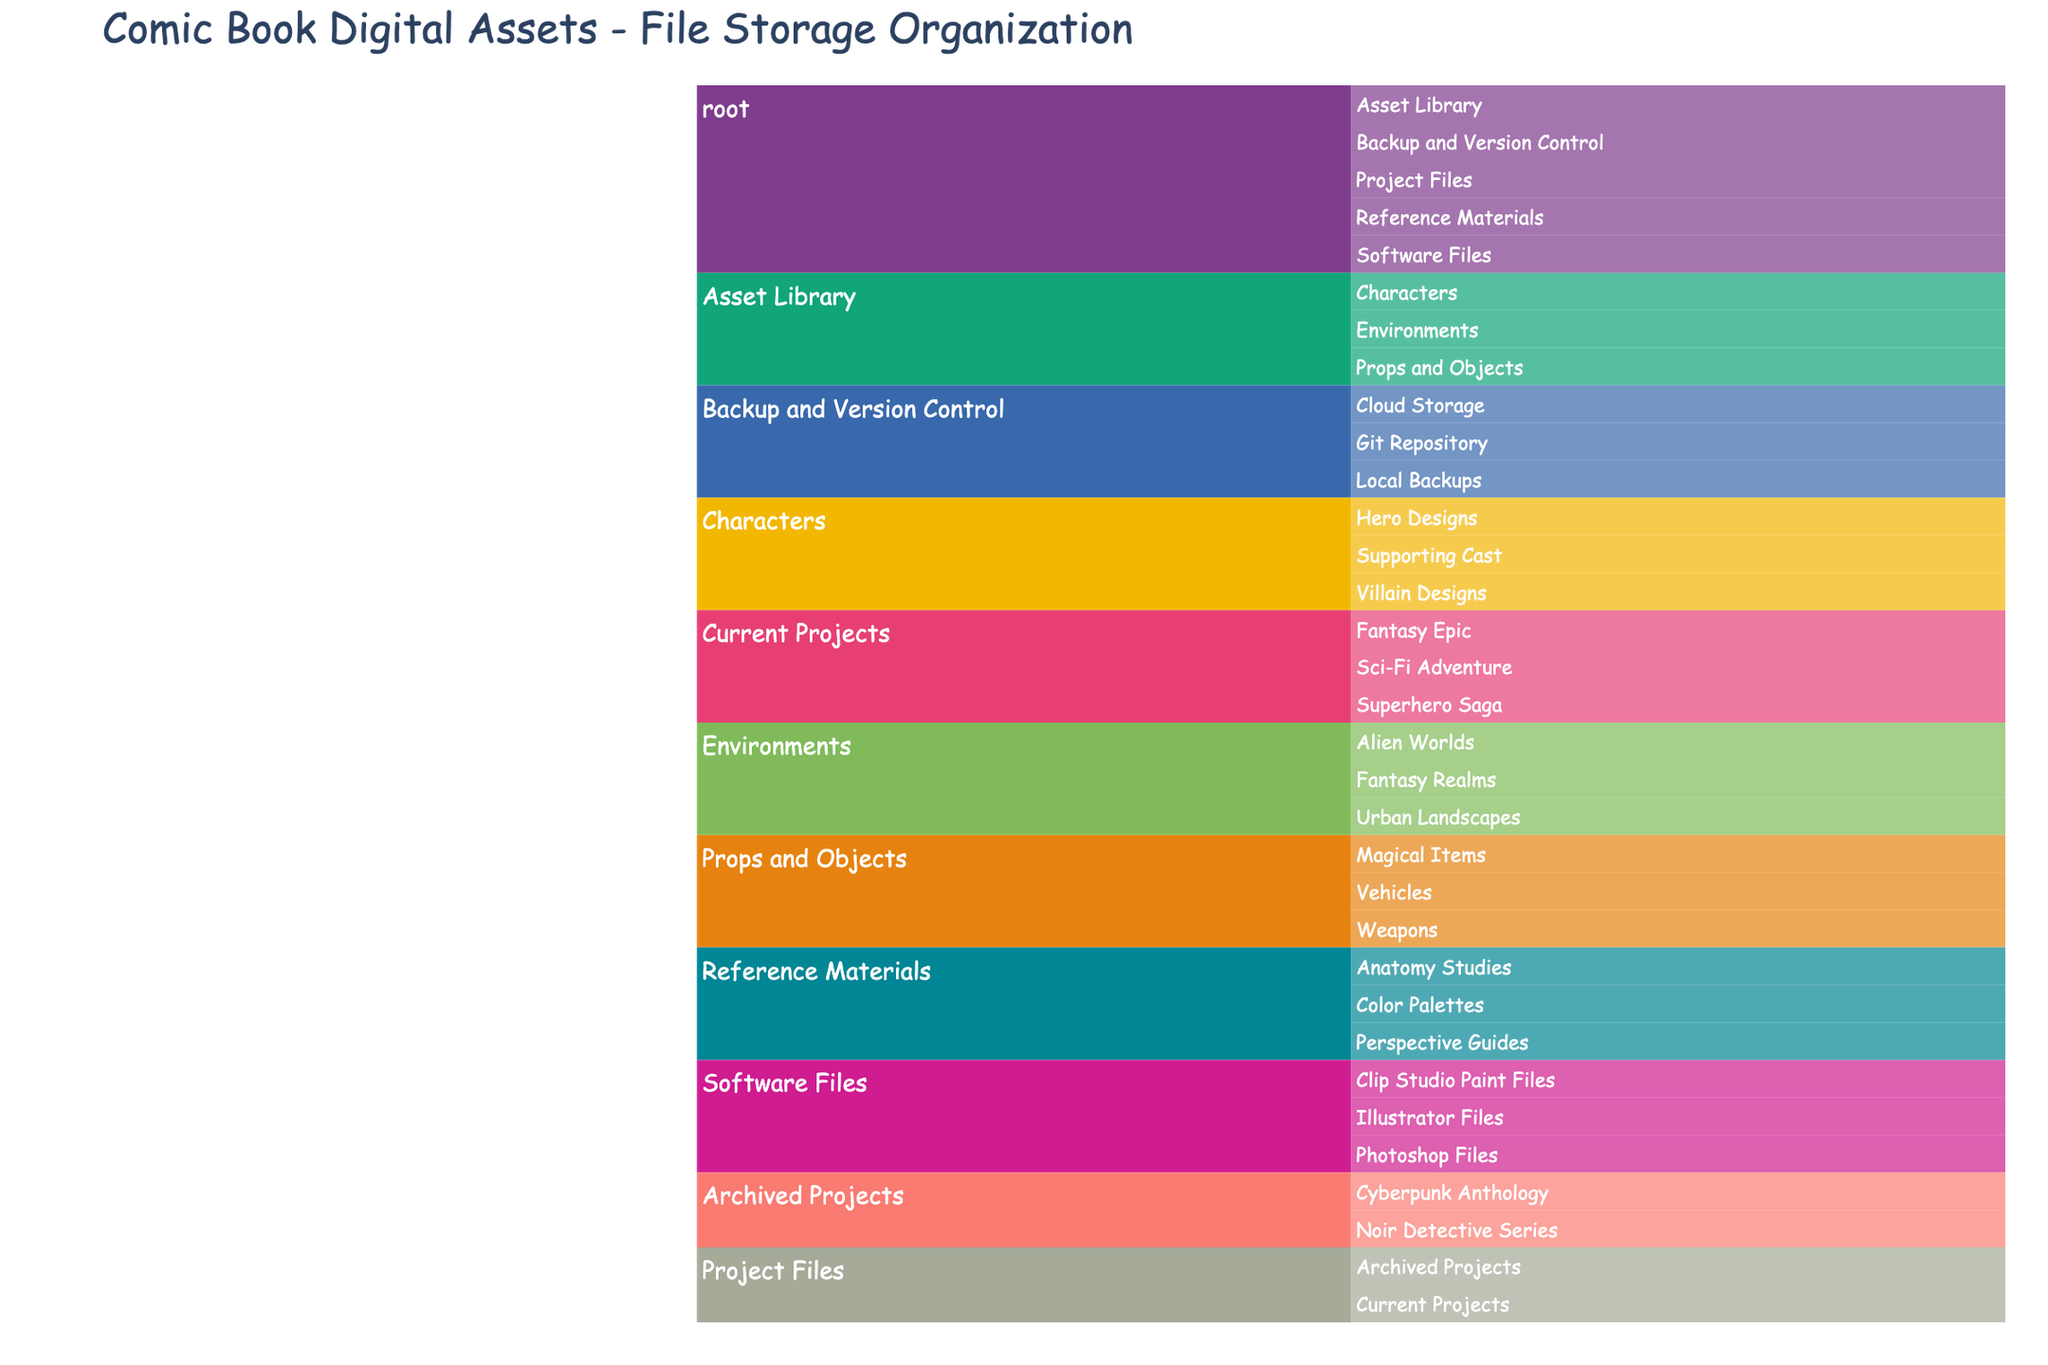What's the title of the Icicle chart? The title is located at the top of the chart, often in a larger or bolder font to make it stand out.
Answer: Comic Book Digital Assets - File Storage Organization How many main categories are there under the root? Observe the first level of branches directly descending from the root node.
Answer: 5 Which project has more subcategories: 'Superhero Saga' or 'Sci-Fi Adventure'? For each project, count the number of branches or subcategories stemming from it. Both have no subcategories, so they are equal.
Answer: They are equal How many subcategories are listed under 'Asset Library'? Look at the branches stemming from 'Asset Library' and count the subcategories.
Answer: 3 Which category under 'Backup and Version Control' involves storing data in a remote location? Identify the category under 'Backup and Version Control' that explicitly mentions a remote storage method.
Answer: Cloud Storage What is the total number of categories under 'Project Files'? Add the subcategories under 'Current Projects' and 'Archived Projects', then sum them up.
Answer: 5 Which subcategory in 'Reference Materials' is specifically related to 'color'? Identify the subcategory under 'Reference Materials' that mentions 'color'.
Answer: Color Palettes Between 'Environments' and 'Props and Objects', which category has more subcategories? Count the number of branches stemming from 'Environments' and 'Props and Objects', then compare the totals.
Answer: They are equal Which file type is not found under 'Software Files'? Match the file types listed under 'Software Files' with common software used by artists: Photoshop, Illustrator, and Clip Studio Paint Files. Identify any common type not listed.
Answer: None How many subcategories fall under 'Characters' in the 'Asset Library'? Count the number of branches stemming from 'Characters'.
Answer: 3 